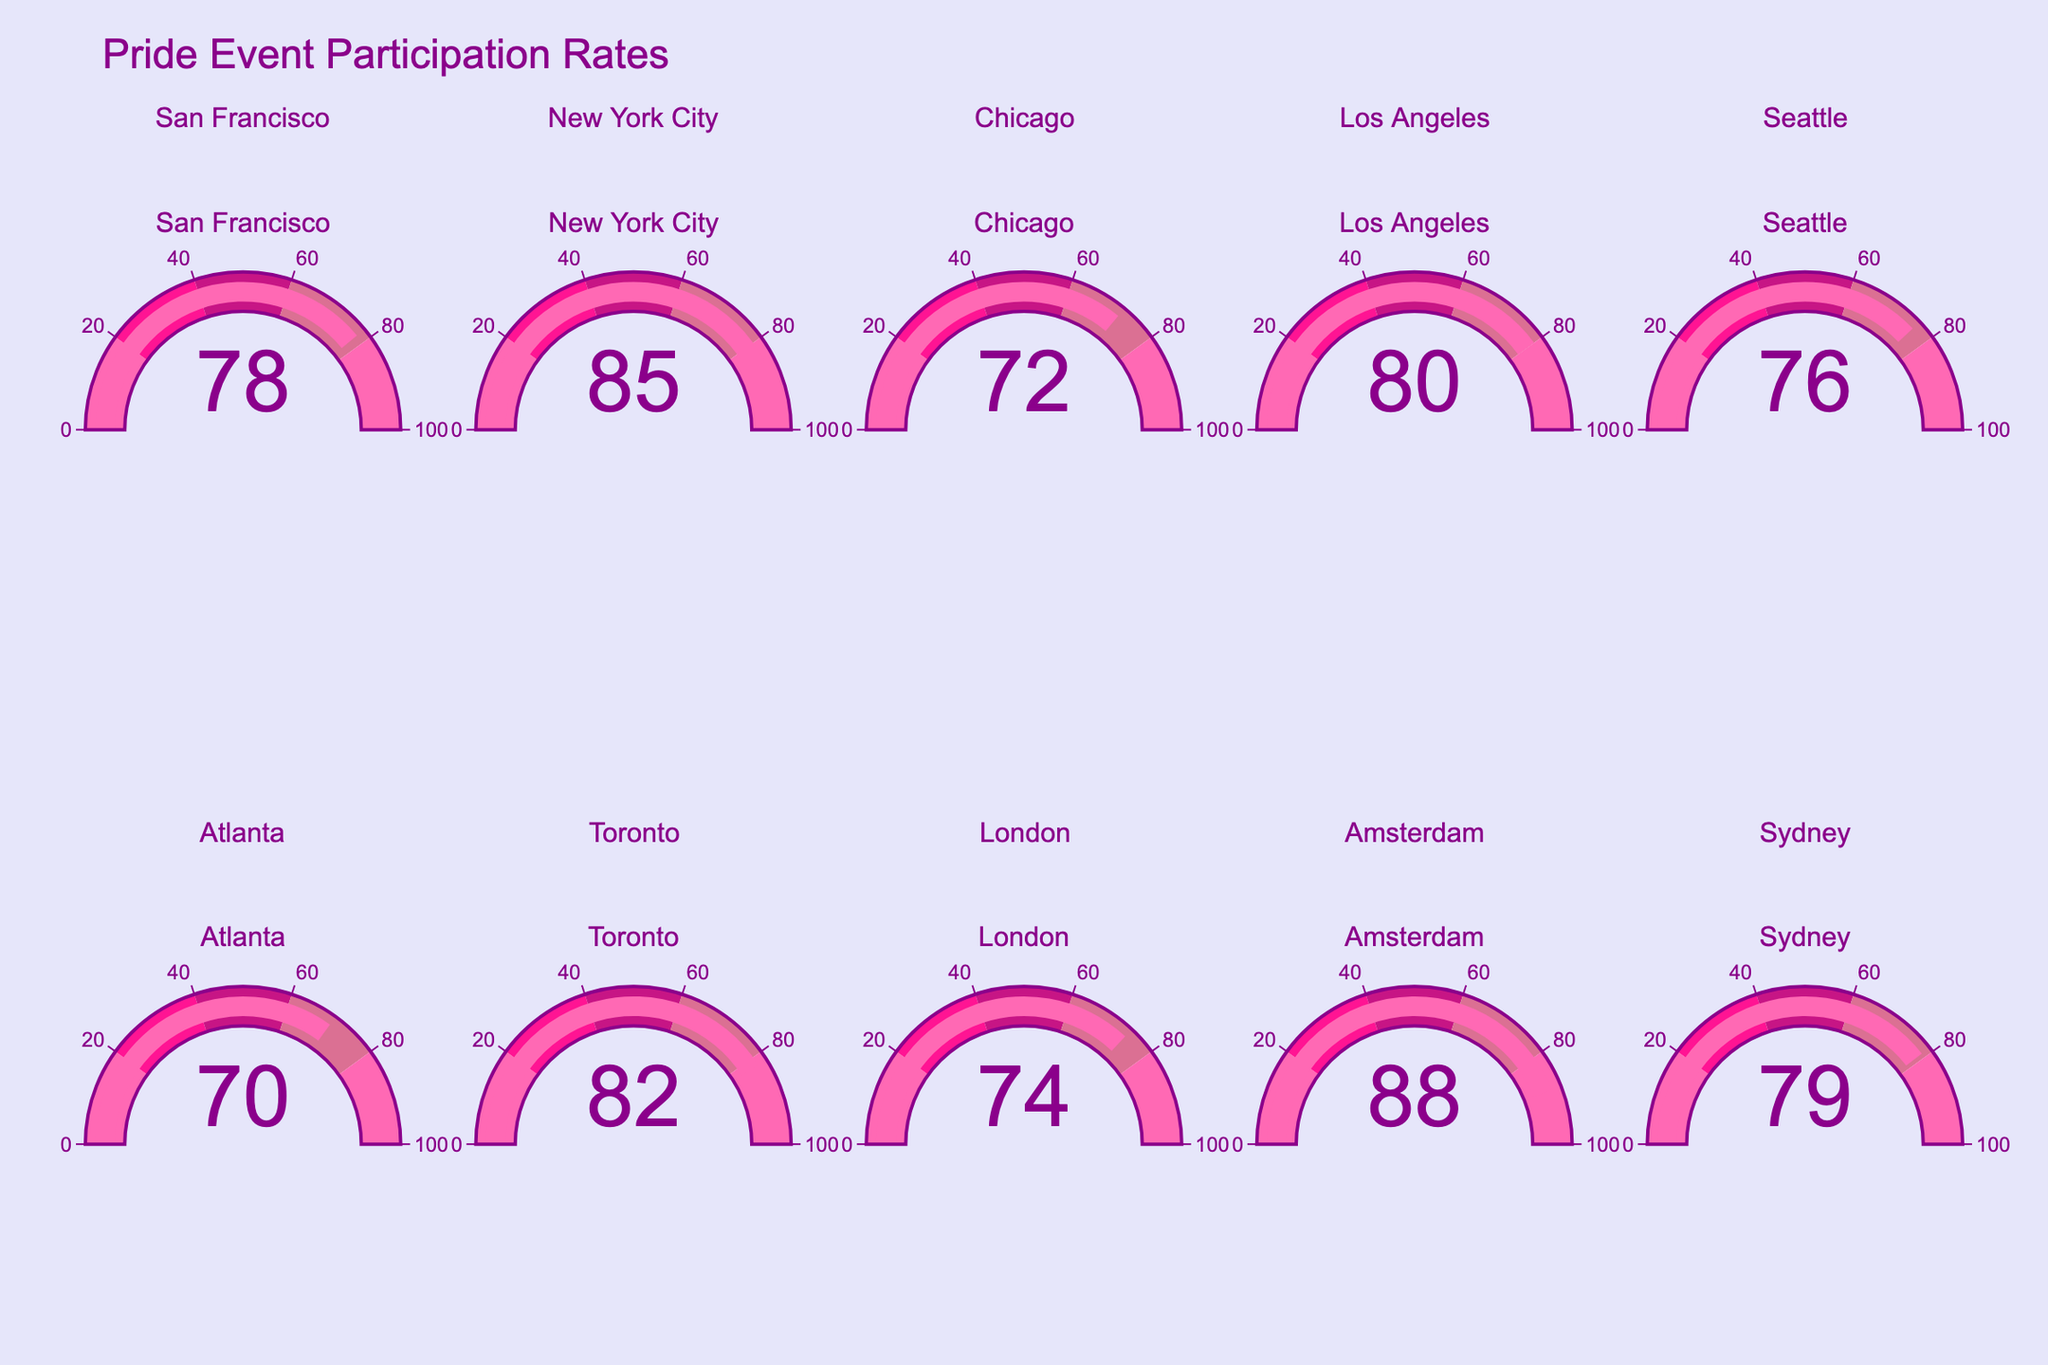What's the participation rate in New York City? The figure displays a gauge for each city showing the participation rate. For New York City, the gauge shows 85.
Answer: 85 Which city has the lowest participation rate? We look at all the gauges and find that Atlanta has the lowest participation rate at 70.
Answer: Atlanta What is the average participation rate across all cities? Adding up all the participation rates: (78 + 85 + 72 + 80 + 76 + 70 + 82 + 74 + 88 + 79) = 784, then dividing by the number of cities, 784 / 10 = 78.4
Answer: 78.4 Which city has a participation rate closest to 75? The gauges show these rates near 75: Seattle (76) and London (74). Comparing the difference, London is closest to 75 with 74.
Answer: London What’s the difference in participation rates between Amsterdam and Chicago? Amsterdam's rate is 88, and Chicago's rate is 72. The difference is 88 - 72 = 16.
Answer: 16 Which city has the highest participation rate? We compare all the gauges and find that Amsterdam has the highest participation rate at 88.
Answer: Amsterdam How many cities have a participation rate above 80? Checking each gauge, the cities above 80 are New York City, Toronto, and Amsterdam, making a total of 3 cities.
Answer: 3 What is the sum of the participation rates of Sydney, San Francisco, and Seattle? Adding the rates: Sydney (79), San Francisco (78), and Seattle (76), the sum is 79 + 78 + 76 = 233.
Answer: 233 Is the participation rate in Toronto greater than that in Los Angeles? Comparing the two gauges, Toronto has 82 while Los Angeles has 80. So, 82 is greater than 80.
Answer: Yes What is the median participation rate of all the cities? Arranging the rates in order: 70, 72, 74, 76, 78, 79, 80, 82, 85, 88. The median, being the average of 5th and 6th values, is (78 + 79)/2 = 78.5.
Answer: 78.5 